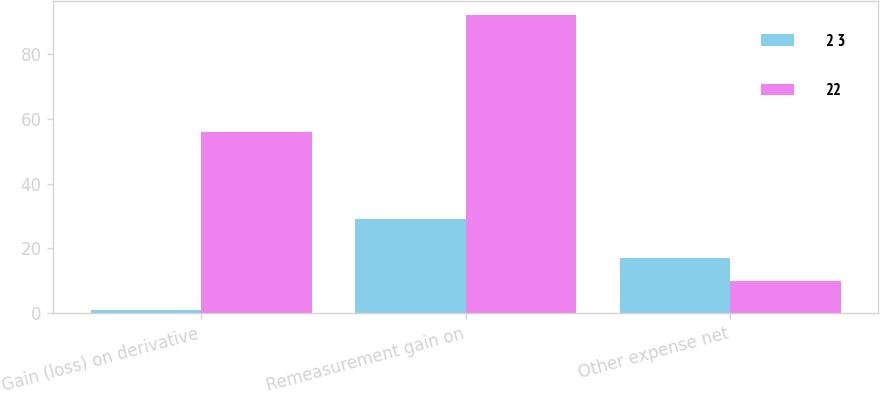<chart> <loc_0><loc_0><loc_500><loc_500><stacked_bar_chart><ecel><fcel>Gain (loss) on derivative<fcel>Remeasurement gain on<fcel>Other expense net<nl><fcel>2 3<fcel>1<fcel>29<fcel>17<nl><fcel>22<fcel>56<fcel>92<fcel>10<nl></chart> 